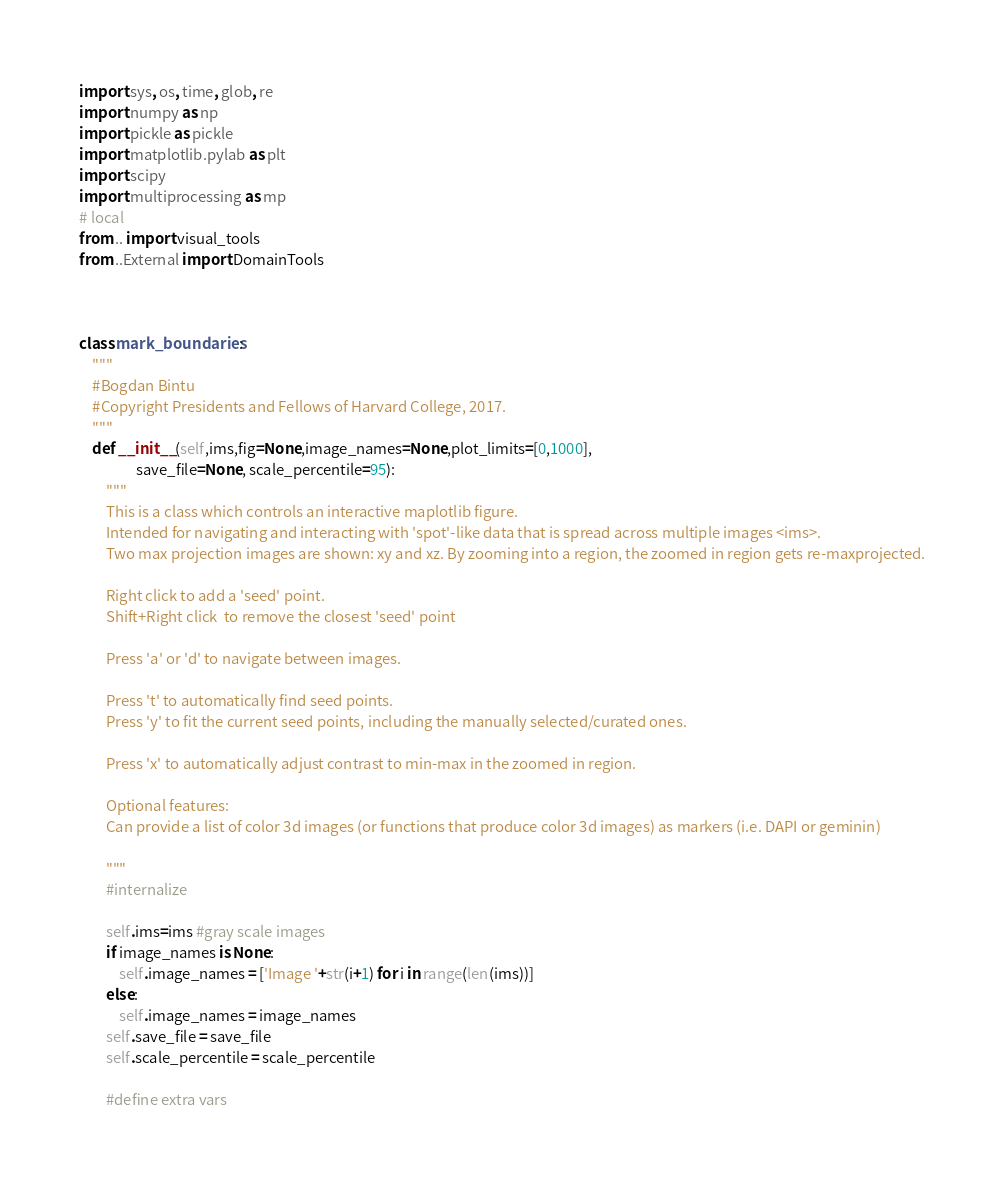<code> <loc_0><loc_0><loc_500><loc_500><_Python_>import sys, os, time, glob, re
import numpy as np
import pickle as pickle
import matplotlib.pylab as plt
import scipy
import multiprocessing as mp
# local
from .. import visual_tools
from ..External import DomainTools



class mark_boundaries:
    """
    #Bogdan Bintu
    #Copyright Presidents and Fellows of Harvard College, 2017.
    """
    def __init__(self,ims,fig=None,image_names=None,plot_limits=[0,1000],
                 save_file=None, scale_percentile=95):
        """
        This is a class which controls an interactive maplotlib figure.
        Intended for navigating and interacting with 'spot'-like data that is spread across multiple images <ims>.
        Two max projection images are shown: xy and xz. By zooming into a region, the zoomed in region gets re-maxprojected.
        
        Right click to add a 'seed' point.
        Shift+Right click  to remove the closest 'seed' point
        
        Press 'a' or 'd' to navigate between images.
        
        Press 't' to automatically find seed points.
        Press 'y' to fit the current seed points, including the manually selected/curated ones.
        
        Press 'x' to automatically adjust contrast to min-max in the zoomed in region.
        
        Optional features:
        Can provide a list of color 3d images (or functions that produce color 3d images) as markers (i.e. DAPI or geminin)
        
        """
        #internalize

        self.ims=ims #gray scale images
        if image_names is None:
            self.image_names = ['Image '+str(i+1) for i in range(len(ims))]
        else:
            self.image_names = image_names
        self.save_file = save_file
        self.scale_percentile = scale_percentile

        #define extra vars</code> 